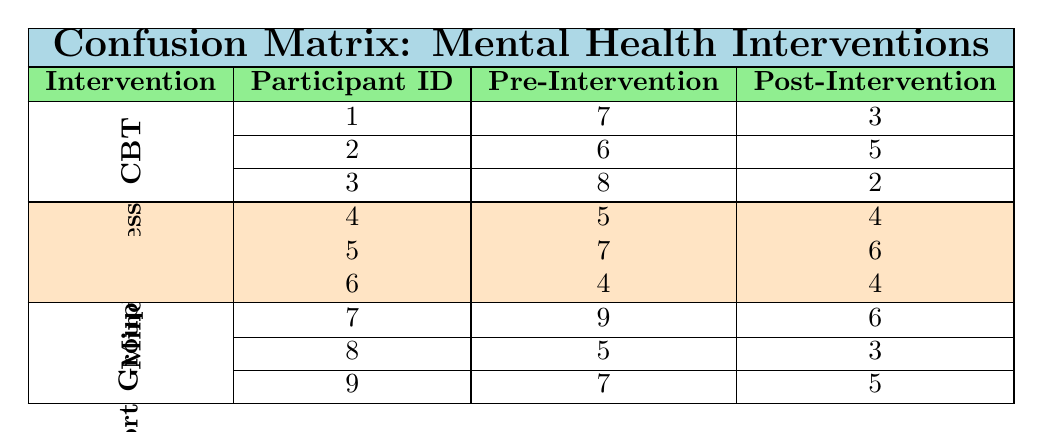What is the pre-intervention anxiety level of participant 1 in the CBT group? The table shows that participant 1 in the CBT group has a pre-intervention anxiety level of 7.
Answer: 7 What is the post-intervention anxiety level of participant 5 in the Mindfulness group? The table indicates that participant 5 in the Mindfulness group has a post-intervention anxiety level of 6.
Answer: 6 How many participants in the Support Group had a reduction in anxiety levels after the intervention? For the Support Group, participants 7, 8, and 9 had post-intervention anxiety levels of 6, 3, and 5 respectively. Participants 7 (from 9 to 6), 8 (from 5 to 3), and 9 (from 7 to 5) all showed a reduction, making a total of 3 participants who experienced a decrease in anxiety.
Answer: 3 What is the average pre-intervention anxiety level across all interventions? To find the average pre-intervention anxiety level: add the values (7 + 6 + 8 + 5 + 7 + 4 + 9 + 5 + 7) = 58. There are 9 participants, so the average is 58/9 = 6.44.
Answer: 6.44 Did participant 6 experience a change in their anxiety level after the Mindfulness intervention? According to the data, participant 6's pre-intervention anxiety level was 4, and the post-intervention level remained 4. This indicates that participant 6 did not experience any change.
Answer: No Which intervention had the maximum decrease in post-intervention anxiety levels among participants? The CBT group had the following decreases: participant 1 decreased from 7 to 3 (4), participant 2 decreased from 6 to 5 (1), and participant 3 decreased from 8 to 2 (6). The maximum decrease in CBT is 6. In the Support Group, the max decrease is also 4 (from 9 to 6). However, in CBT, participant 3 had the highest decrease of 6, making CBT the intervention with the maximum decrease.
Answer: CBT What is the total pre-intervention anxiety level of all participants in the Mindfulness intervention? The pre-intervention levels for participants 4, 5, and 6 in the Mindfulness group are 5, 7, and 4 respectively. Adding these values: 5 + 7 + 4 = 16.
Answer: 16 Which participant had the most severe pre-intervention anxiety level in the table? From the data provided, pre-intervention anxiety levels are as follows: participant 1 (7), participant 2 (6), participant 3 (8), participant 4 (5), participant 5 (7), participant 6 (4), participant 7 (9), participant 8 (5), and participant 9 (7). Participant 7 has the highest level at 9.
Answer: Participant 7 